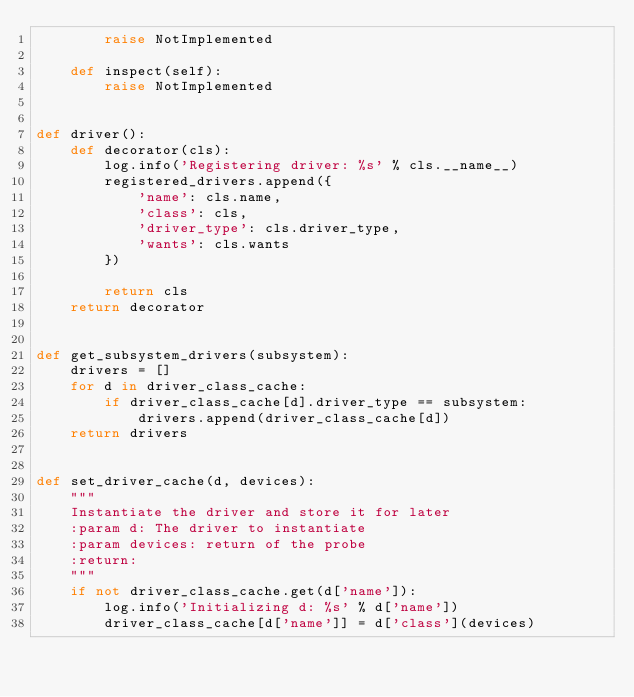Convert code to text. <code><loc_0><loc_0><loc_500><loc_500><_Python_>        raise NotImplemented

    def inspect(self):
        raise NotImplemented


def driver():
    def decorator(cls):
        log.info('Registering driver: %s' % cls.__name__)
        registered_drivers.append({
            'name': cls.name,
            'class': cls,
            'driver_type': cls.driver_type,
            'wants': cls.wants
        })

        return cls
    return decorator


def get_subsystem_drivers(subsystem):
    drivers = []
    for d in driver_class_cache:
        if driver_class_cache[d].driver_type == subsystem:
            drivers.append(driver_class_cache[d])
    return drivers


def set_driver_cache(d, devices):
    """
    Instantiate the driver and store it for later
    :param d: The driver to instantiate
    :param devices: return of the probe
    :return:
    """
    if not driver_class_cache.get(d['name']):
        log.info('Initializing d: %s' % d['name'])
        driver_class_cache[d['name']] = d['class'](devices)
</code> 